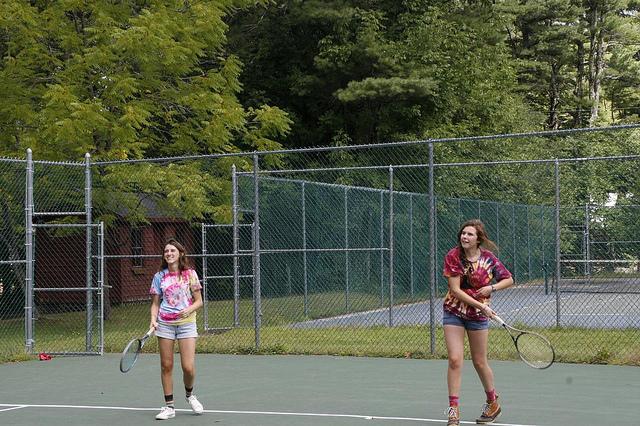Are they fencing?
Quick response, please. No. Is the woman serving?
Concise answer only. Yes. Is she talking on the phone?
Write a very short answer. No. How many people are smoking?
Concise answer only. 0. How many children are in the picture?
Write a very short answer. 2. Are the girls playing doubles?
Keep it brief. Yes. What sport is this?
Give a very brief answer. Tennis. 